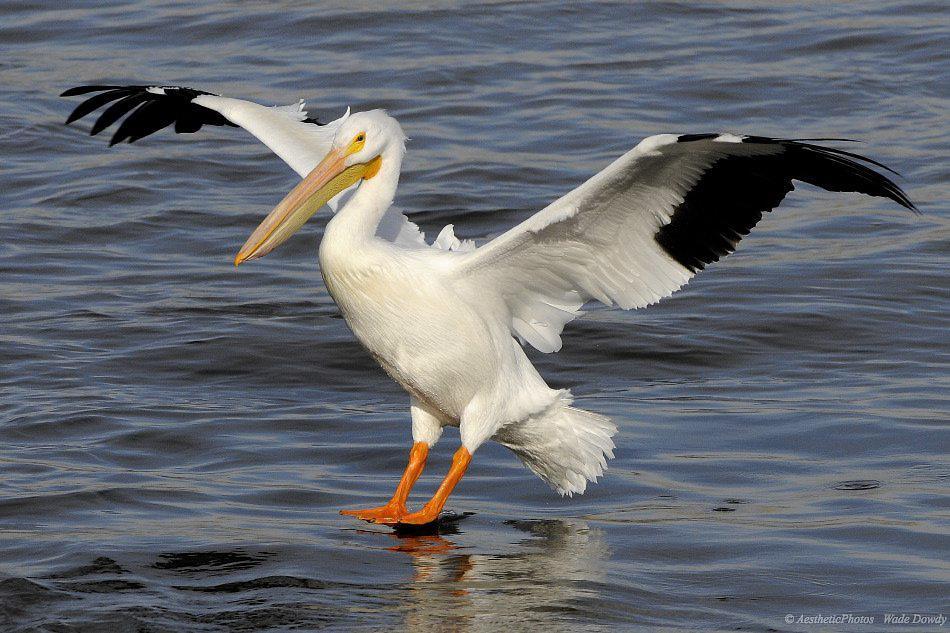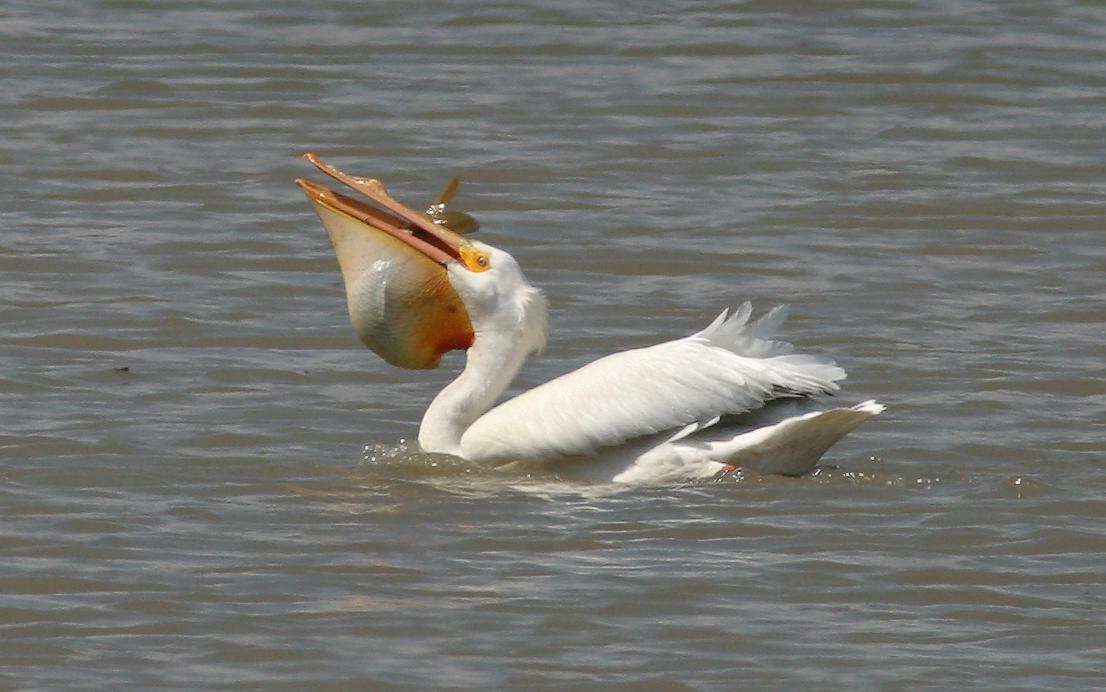The first image is the image on the left, the second image is the image on the right. Considering the images on both sides, is "An image shows a leftward floating pelican with a fish in its bill." valid? Answer yes or no. Yes. The first image is the image on the left, the second image is the image on the right. Examine the images to the left and right. Is the description "The bird in the left image is facing towards the left." accurate? Answer yes or no. Yes. 